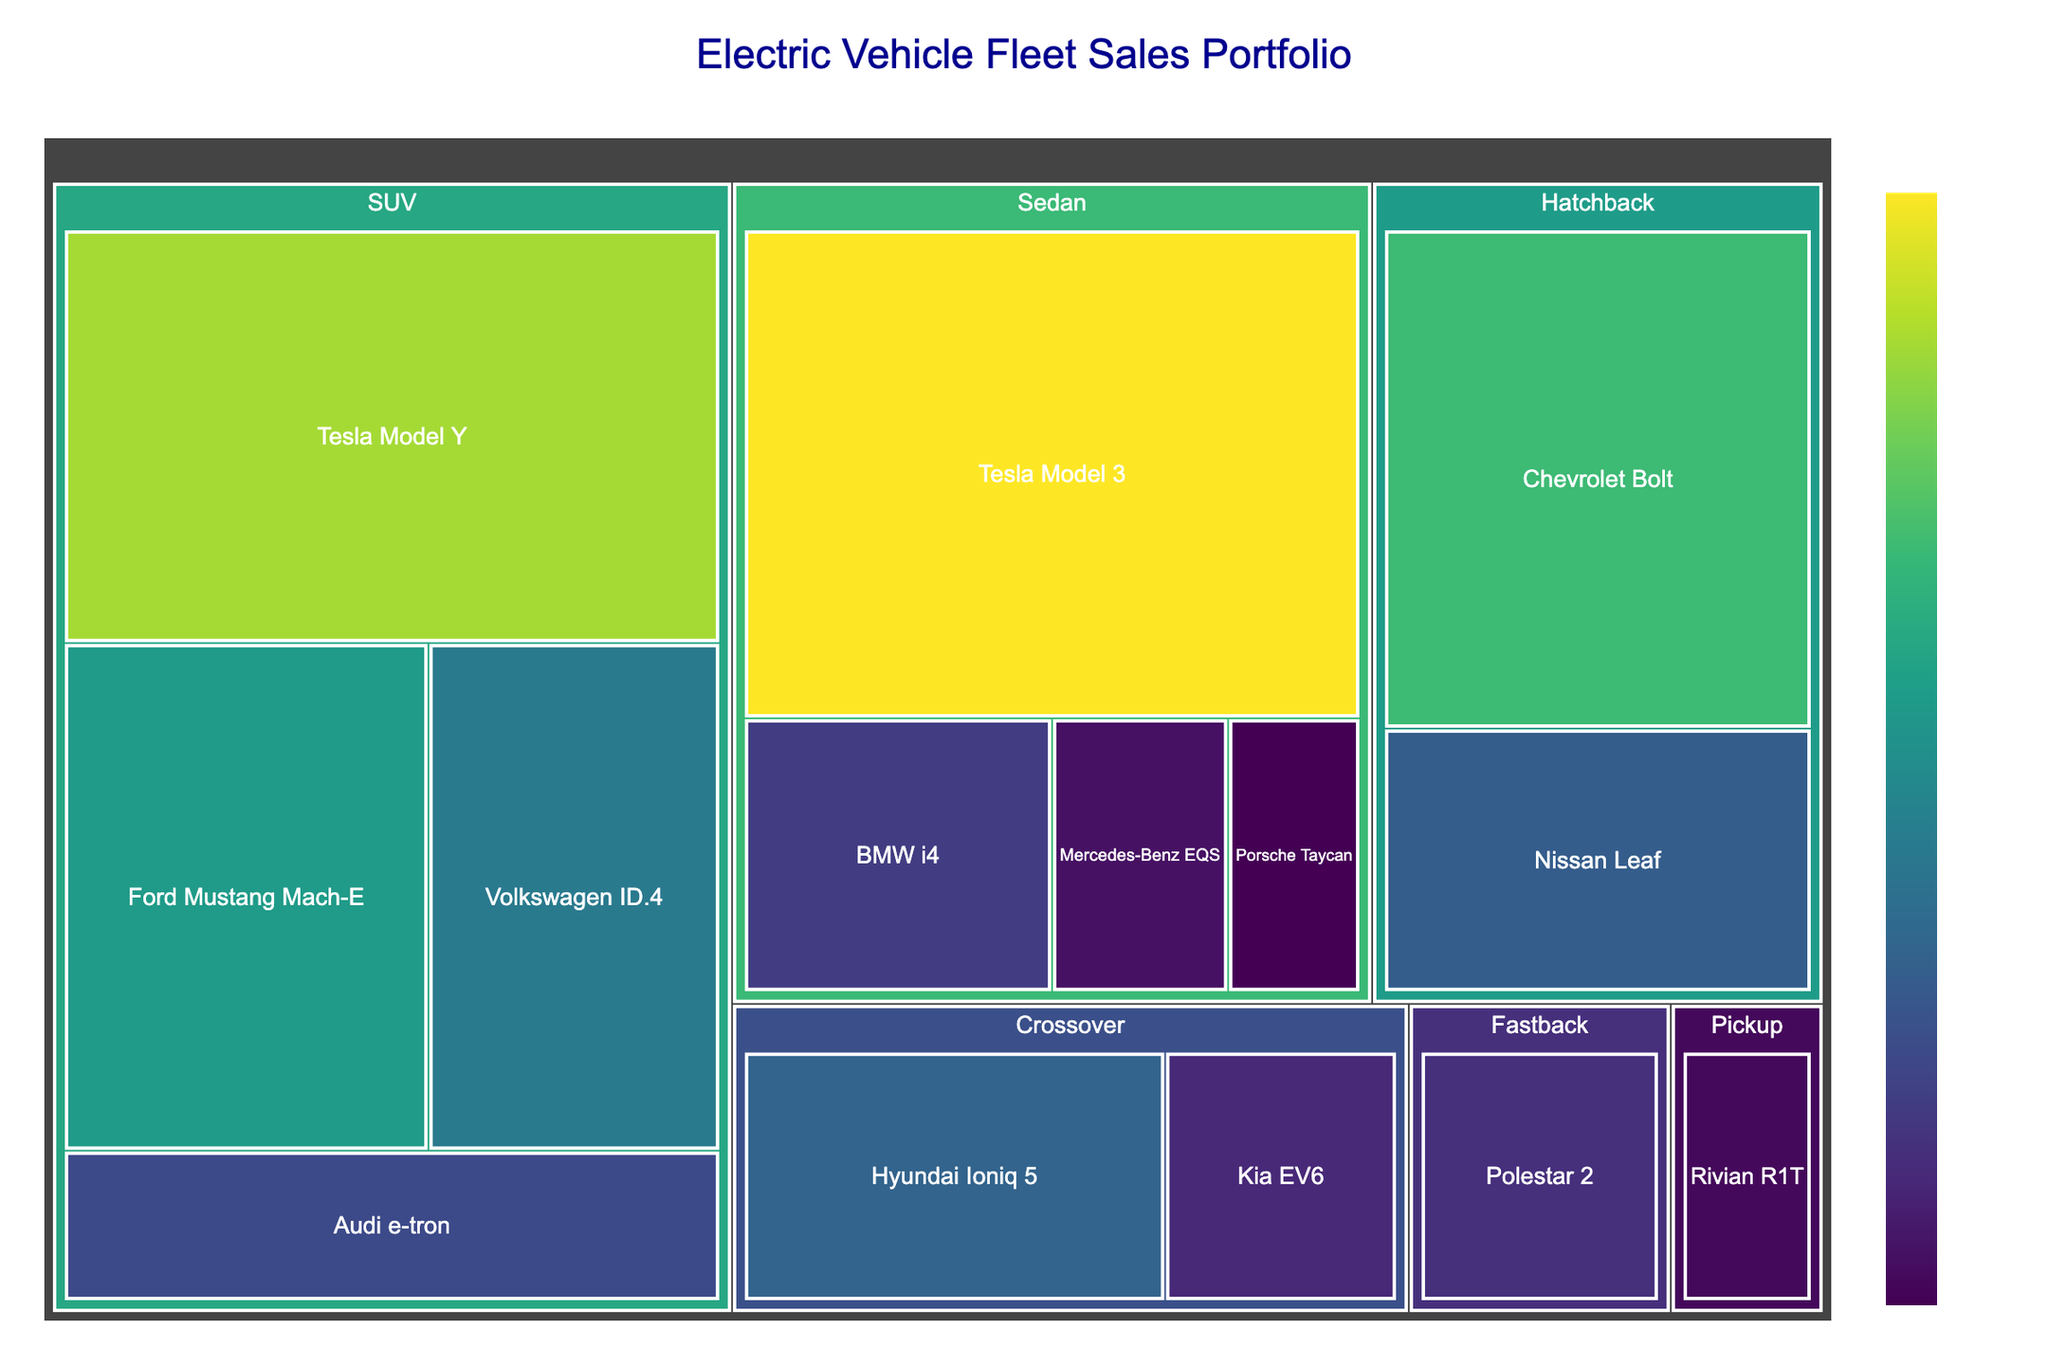What's the most sold electric vehicle model in the fleet sales portfolio? The Tesla Model 3 appears to have the largest area in the treemap, indicating the highest number of units sold.
Answer: Tesla Model 3 What's the total number of units sold for SUVs? Combine the units sold for all SUV models: Tesla Model Y (2200), Ford Mustang Mach-E (1500), Volkswagen ID.4 (1200), and Audi e-tron (800). The sum is 2200 + 1500 + 1200 + 800 = 5700.
Answer: 5700 Which category has fewer total units sold, Sedans or Crossovers? Add up the units sold for each model in both categories. Sedans: Tesla Model 3 (2500), BMW i4 (700), Mercedes-Benz EQS (400), Porsche Taycan (300) with a total of 2500 + 700 + 400 + 300 = 3900. Crossovers: Hyundai Ioniq 5 (1000), Kia EV6 (550) with a total of 1000 + 550 = 1550. Compare the totals to conclude that Crossovers have fewer units sold.
Answer: Crossovers What's the difference in units sold between the best-selling and least-selling models? The best-selling model is the Tesla Model 3 with 2500 units, and the least-selling model is the Porsche Taycan with 300 units. The difference is 2500 - 300 = 2200.
Answer: 2200 Which models fall into the Hatchback category, and how many units were sold in total? Identify the Hatchback models: Chevrolet Bolt (1800) and Nissan Leaf (950). The total units sold for Hatchbacks are 1800 + 950 = 2750.
Answer: Chevrolet Bolt, Nissan Leaf; 2750 How many categories of electric vehicles are represented in the treemap? The treemap categorizes the electric vehicles into different groups. By counting the distinct groups, you can see there are six categories: Sedan, SUV, Hatchback, Crossover, Fastback, and Pickup.
Answer: 6 What's the ratio of units sold between the Tesla Model Y and Ford Mustang Mach-E? The Tesla Model Y sold 2200 units and the Ford Mustang Mach-E sold 1500 units. The ratio of their units sold is 2200/1500, which simplifies to approximately 1.47.
Answer: 1.47 What's the average number of units sold per model in the Sedan category? Sum the units sold for all Sedan models: Tesla Model 3 (2500), BMW i4 (700), Mercedes-Benz EQS (400), Porsche Taycan (300). The total is 2500 + 700 + 400 + 300 = 3900. There are 4 models, so the average is 3900/4 = 975.
Answer: 975 